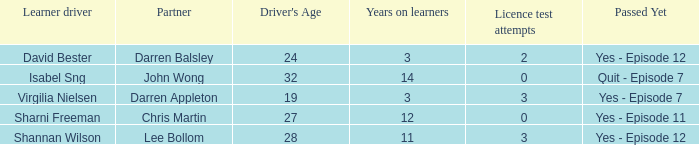Can you parse all the data within this table? {'header': ['Learner driver', 'Partner', "Driver's Age", 'Years on learners', 'Licence test attempts', 'Passed Yet'], 'rows': [['David Bester', 'Darren Balsley', '24', '3', '2', 'Yes - Episode 12'], ['Isabel Sng', 'John Wong', '32', '14', '0', 'Quit - Episode 7'], ['Virgilia Nielsen', 'Darren Appleton', '19', '3', '3', 'Yes - Episode 7'], ['Sharni Freeman', 'Chris Martin', '27', '12', '0', 'Yes - Episode 11'], ['Shannan Wilson', 'Lee Bollom', '28', '11', '3', 'Yes - Episode 12']]} Which driver is older than 24 and has more than 0 licence test attempts? Shannan Wilson. 